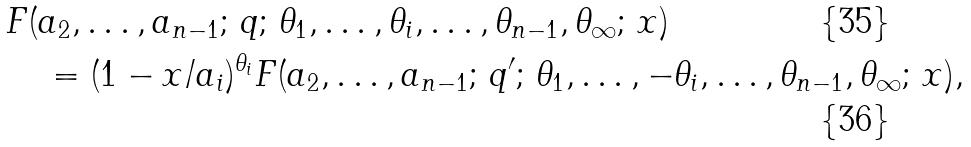Convert formula to latex. <formula><loc_0><loc_0><loc_500><loc_500>& F ( a _ { 2 } , \dots , a _ { n - 1 } ; \, q ; \, \theta _ { 1 } , \dots , \theta _ { i } , \dots , \theta _ { n - 1 } , \theta _ { \infty } ; \, x ) \\ & \quad = ( 1 - x / a _ { i } ) ^ { \theta _ { i } } F ( a _ { 2 } , \dots , a _ { n - 1 } ; \, q ^ { \prime } ; \, \theta _ { 1 } , \dots , - \theta _ { i } , \dots , \theta _ { n - 1 } , \theta _ { \infty } ; \, x ) ,</formula> 